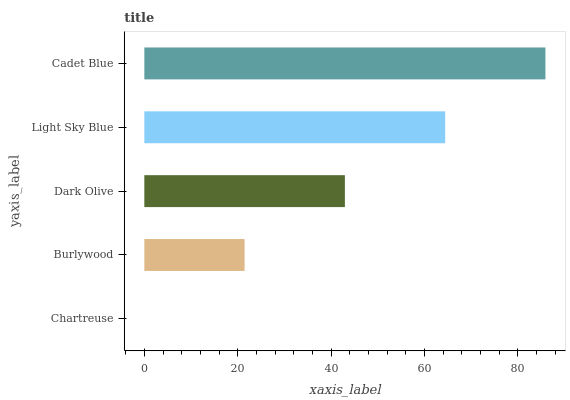Is Chartreuse the minimum?
Answer yes or no. Yes. Is Cadet Blue the maximum?
Answer yes or no. Yes. Is Burlywood the minimum?
Answer yes or no. No. Is Burlywood the maximum?
Answer yes or no. No. Is Burlywood greater than Chartreuse?
Answer yes or no. Yes. Is Chartreuse less than Burlywood?
Answer yes or no. Yes. Is Chartreuse greater than Burlywood?
Answer yes or no. No. Is Burlywood less than Chartreuse?
Answer yes or no. No. Is Dark Olive the high median?
Answer yes or no. Yes. Is Dark Olive the low median?
Answer yes or no. Yes. Is Cadet Blue the high median?
Answer yes or no. No. Is Light Sky Blue the low median?
Answer yes or no. No. 